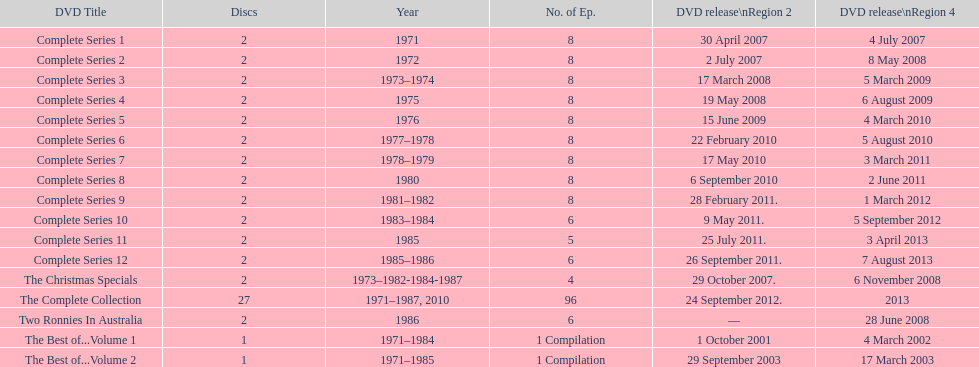In 2007, what was the total count of episodes launched in region 2? 20. 